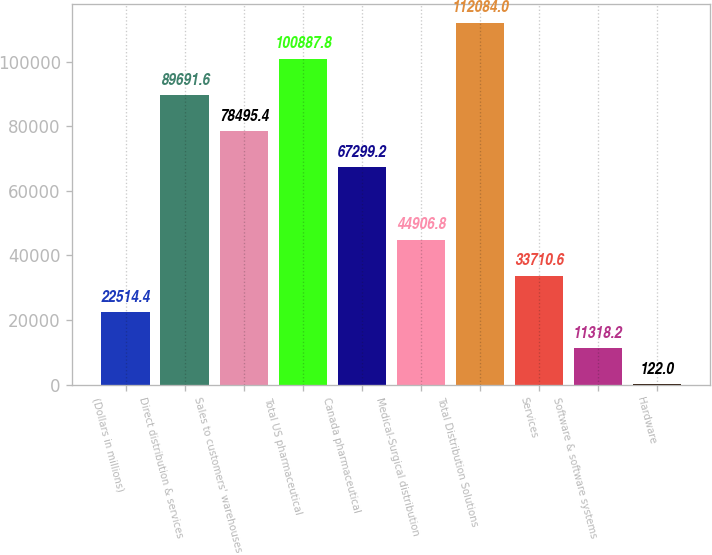<chart> <loc_0><loc_0><loc_500><loc_500><bar_chart><fcel>(Dollars in millions)<fcel>Direct distribution & services<fcel>Sales to customers' warehouses<fcel>Total US pharmaceutical<fcel>Canada pharmaceutical<fcel>Medical-Surgical distribution<fcel>Total Distribution Solutions<fcel>Services<fcel>Software & software systems<fcel>Hardware<nl><fcel>22514.4<fcel>89691.6<fcel>78495.4<fcel>100888<fcel>67299.2<fcel>44906.8<fcel>112084<fcel>33710.6<fcel>11318.2<fcel>122<nl></chart> 